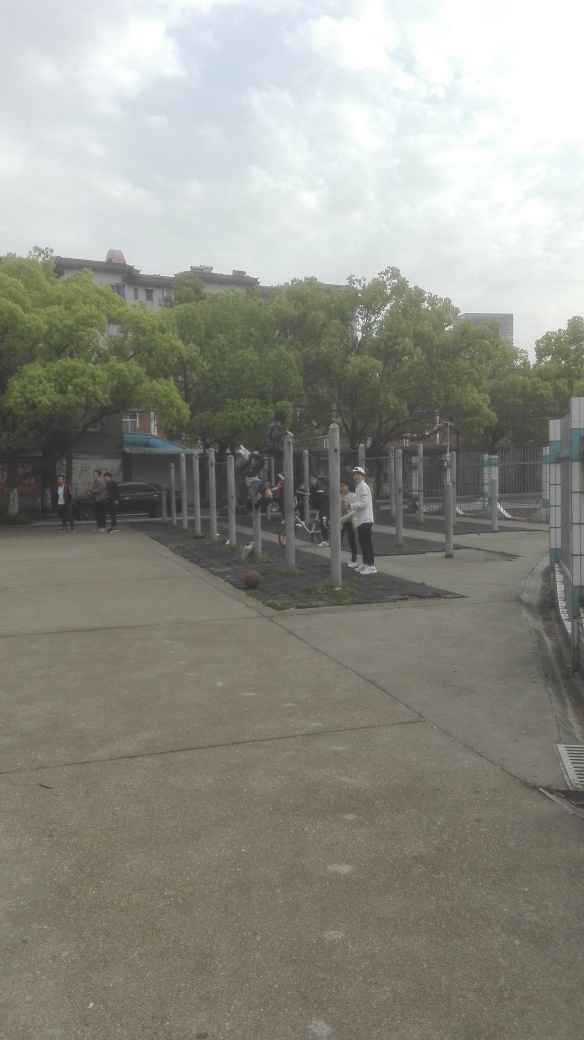Can you describe the weather in the image? It appears to be a daytime scene with overcast weather, as the sky is quite cloudy. However, visibility seems good, and there's enough daylight for outdoor activities, suggesting it is neither too early nor too late in the day. Does the weather seem to affect the ambiance of the scene? The clouds may add a somewhat subdued or calm ambiance to the scene. Despite the overcast sky, the people in the image are actively engaging in exercises, suggesting that the weather is suitable for outdoor physical activity without discomfort. 